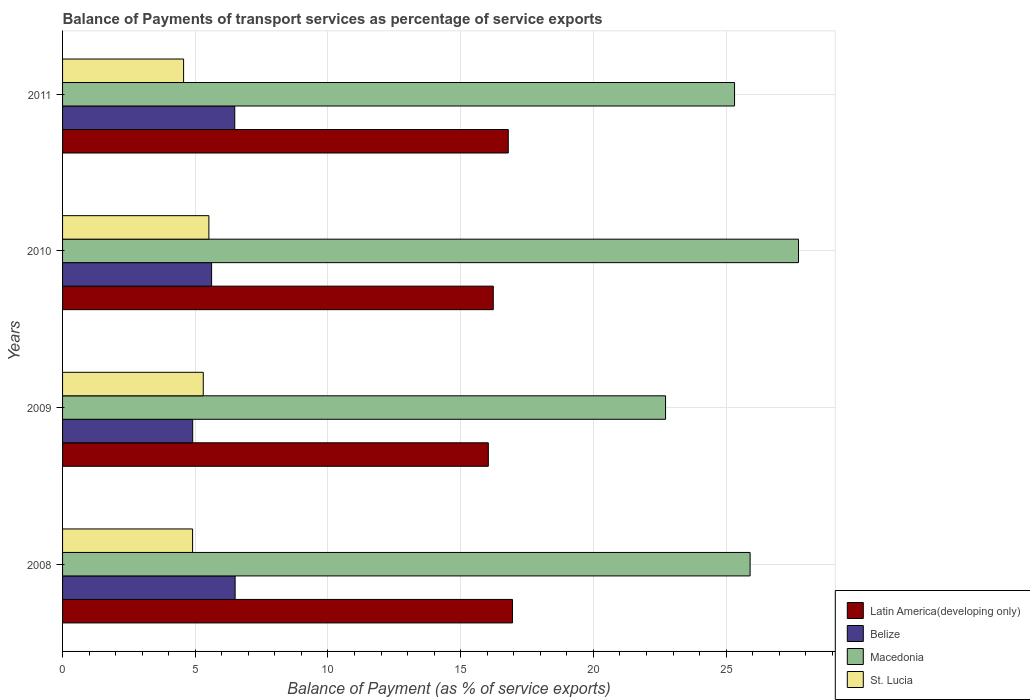How many different coloured bars are there?
Provide a short and direct response. 4. Are the number of bars per tick equal to the number of legend labels?
Ensure brevity in your answer.  Yes. Are the number of bars on each tick of the Y-axis equal?
Your answer should be very brief. Yes. How many bars are there on the 2nd tick from the top?
Make the answer very short. 4. How many bars are there on the 3rd tick from the bottom?
Your answer should be compact. 4. What is the label of the 4th group of bars from the top?
Offer a terse response. 2008. What is the balance of payments of transport services in Macedonia in 2008?
Your answer should be compact. 25.91. Across all years, what is the maximum balance of payments of transport services in St. Lucia?
Keep it short and to the point. 5.51. Across all years, what is the minimum balance of payments of transport services in Latin America(developing only)?
Provide a succinct answer. 16.04. In which year was the balance of payments of transport services in Belize minimum?
Keep it short and to the point. 2009. What is the total balance of payments of transport services in Belize in the graph?
Offer a terse response. 23.51. What is the difference between the balance of payments of transport services in Latin America(developing only) in 2009 and that in 2010?
Provide a succinct answer. -0.19. What is the difference between the balance of payments of transport services in Belize in 2009 and the balance of payments of transport services in Latin America(developing only) in 2008?
Your answer should be very brief. -12.05. What is the average balance of payments of transport services in Belize per year?
Ensure brevity in your answer.  5.88. In the year 2008, what is the difference between the balance of payments of transport services in Belize and balance of payments of transport services in St. Lucia?
Your response must be concise. 1.6. In how many years, is the balance of payments of transport services in Belize greater than 23 %?
Provide a short and direct response. 0. What is the ratio of the balance of payments of transport services in Latin America(developing only) in 2010 to that in 2011?
Keep it short and to the point. 0.97. Is the balance of payments of transport services in Belize in 2008 less than that in 2010?
Ensure brevity in your answer.  No. Is the difference between the balance of payments of transport services in Belize in 2008 and 2010 greater than the difference between the balance of payments of transport services in St. Lucia in 2008 and 2010?
Keep it short and to the point. Yes. What is the difference between the highest and the second highest balance of payments of transport services in Latin America(developing only)?
Offer a very short reply. 0.16. What is the difference between the highest and the lowest balance of payments of transport services in Latin America(developing only)?
Provide a short and direct response. 0.91. Is it the case that in every year, the sum of the balance of payments of transport services in Belize and balance of payments of transport services in Macedonia is greater than the sum of balance of payments of transport services in St. Lucia and balance of payments of transport services in Latin America(developing only)?
Offer a very short reply. Yes. What does the 3rd bar from the top in 2010 represents?
Offer a terse response. Belize. What does the 4th bar from the bottom in 2011 represents?
Offer a very short reply. St. Lucia. How many years are there in the graph?
Offer a terse response. 4. What is the difference between two consecutive major ticks on the X-axis?
Give a very brief answer. 5. Does the graph contain any zero values?
Your response must be concise. No. Where does the legend appear in the graph?
Give a very brief answer. Bottom right. How are the legend labels stacked?
Your answer should be compact. Vertical. What is the title of the graph?
Ensure brevity in your answer.  Balance of Payments of transport services as percentage of service exports. What is the label or title of the X-axis?
Provide a short and direct response. Balance of Payment (as % of service exports). What is the label or title of the Y-axis?
Your answer should be compact. Years. What is the Balance of Payment (as % of service exports) in Latin America(developing only) in 2008?
Provide a short and direct response. 16.95. What is the Balance of Payment (as % of service exports) in Belize in 2008?
Provide a succinct answer. 6.5. What is the Balance of Payment (as % of service exports) of Macedonia in 2008?
Provide a succinct answer. 25.91. What is the Balance of Payment (as % of service exports) in St. Lucia in 2008?
Keep it short and to the point. 4.9. What is the Balance of Payment (as % of service exports) in Latin America(developing only) in 2009?
Offer a terse response. 16.04. What is the Balance of Payment (as % of service exports) in Belize in 2009?
Your response must be concise. 4.9. What is the Balance of Payment (as % of service exports) of Macedonia in 2009?
Offer a very short reply. 22.72. What is the Balance of Payment (as % of service exports) of St. Lucia in 2009?
Make the answer very short. 5.3. What is the Balance of Payment (as % of service exports) of Latin America(developing only) in 2010?
Your answer should be compact. 16.23. What is the Balance of Payment (as % of service exports) of Belize in 2010?
Keep it short and to the point. 5.62. What is the Balance of Payment (as % of service exports) in Macedonia in 2010?
Make the answer very short. 27.73. What is the Balance of Payment (as % of service exports) of St. Lucia in 2010?
Offer a very short reply. 5.51. What is the Balance of Payment (as % of service exports) in Latin America(developing only) in 2011?
Your answer should be very brief. 16.79. What is the Balance of Payment (as % of service exports) in Belize in 2011?
Give a very brief answer. 6.49. What is the Balance of Payment (as % of service exports) of Macedonia in 2011?
Your answer should be compact. 25.32. What is the Balance of Payment (as % of service exports) of St. Lucia in 2011?
Give a very brief answer. 4.56. Across all years, what is the maximum Balance of Payment (as % of service exports) in Latin America(developing only)?
Provide a succinct answer. 16.95. Across all years, what is the maximum Balance of Payment (as % of service exports) of Belize?
Make the answer very short. 6.5. Across all years, what is the maximum Balance of Payment (as % of service exports) in Macedonia?
Ensure brevity in your answer.  27.73. Across all years, what is the maximum Balance of Payment (as % of service exports) in St. Lucia?
Your answer should be very brief. 5.51. Across all years, what is the minimum Balance of Payment (as % of service exports) in Latin America(developing only)?
Keep it short and to the point. 16.04. Across all years, what is the minimum Balance of Payment (as % of service exports) in Belize?
Your response must be concise. 4.9. Across all years, what is the minimum Balance of Payment (as % of service exports) in Macedonia?
Your answer should be very brief. 22.72. Across all years, what is the minimum Balance of Payment (as % of service exports) in St. Lucia?
Your response must be concise. 4.56. What is the total Balance of Payment (as % of service exports) of Latin America(developing only) in the graph?
Offer a very short reply. 66.02. What is the total Balance of Payment (as % of service exports) in Belize in the graph?
Your answer should be compact. 23.51. What is the total Balance of Payment (as % of service exports) in Macedonia in the graph?
Your answer should be compact. 101.67. What is the total Balance of Payment (as % of service exports) of St. Lucia in the graph?
Give a very brief answer. 20.27. What is the difference between the Balance of Payment (as % of service exports) in Latin America(developing only) in 2008 and that in 2009?
Provide a short and direct response. 0.91. What is the difference between the Balance of Payment (as % of service exports) of Belize in 2008 and that in 2009?
Offer a very short reply. 1.6. What is the difference between the Balance of Payment (as % of service exports) in Macedonia in 2008 and that in 2009?
Provide a succinct answer. 3.19. What is the difference between the Balance of Payment (as % of service exports) in St. Lucia in 2008 and that in 2009?
Make the answer very short. -0.4. What is the difference between the Balance of Payment (as % of service exports) of Latin America(developing only) in 2008 and that in 2010?
Your response must be concise. 0.72. What is the difference between the Balance of Payment (as % of service exports) in Belize in 2008 and that in 2010?
Your answer should be compact. 0.89. What is the difference between the Balance of Payment (as % of service exports) in Macedonia in 2008 and that in 2010?
Offer a terse response. -1.82. What is the difference between the Balance of Payment (as % of service exports) of St. Lucia in 2008 and that in 2010?
Offer a very short reply. -0.61. What is the difference between the Balance of Payment (as % of service exports) of Latin America(developing only) in 2008 and that in 2011?
Your answer should be very brief. 0.16. What is the difference between the Balance of Payment (as % of service exports) in Belize in 2008 and that in 2011?
Keep it short and to the point. 0.01. What is the difference between the Balance of Payment (as % of service exports) of Macedonia in 2008 and that in 2011?
Keep it short and to the point. 0.59. What is the difference between the Balance of Payment (as % of service exports) in St. Lucia in 2008 and that in 2011?
Keep it short and to the point. 0.34. What is the difference between the Balance of Payment (as % of service exports) in Latin America(developing only) in 2009 and that in 2010?
Give a very brief answer. -0.19. What is the difference between the Balance of Payment (as % of service exports) in Belize in 2009 and that in 2010?
Provide a short and direct response. -0.71. What is the difference between the Balance of Payment (as % of service exports) in Macedonia in 2009 and that in 2010?
Give a very brief answer. -5.01. What is the difference between the Balance of Payment (as % of service exports) of St. Lucia in 2009 and that in 2010?
Your answer should be very brief. -0.21. What is the difference between the Balance of Payment (as % of service exports) in Latin America(developing only) in 2009 and that in 2011?
Keep it short and to the point. -0.75. What is the difference between the Balance of Payment (as % of service exports) in Belize in 2009 and that in 2011?
Your answer should be compact. -1.59. What is the difference between the Balance of Payment (as % of service exports) of Macedonia in 2009 and that in 2011?
Offer a terse response. -2.6. What is the difference between the Balance of Payment (as % of service exports) of St. Lucia in 2009 and that in 2011?
Provide a short and direct response. 0.74. What is the difference between the Balance of Payment (as % of service exports) in Latin America(developing only) in 2010 and that in 2011?
Your answer should be very brief. -0.56. What is the difference between the Balance of Payment (as % of service exports) in Belize in 2010 and that in 2011?
Your response must be concise. -0.87. What is the difference between the Balance of Payment (as % of service exports) in Macedonia in 2010 and that in 2011?
Offer a terse response. 2.41. What is the difference between the Balance of Payment (as % of service exports) of St. Lucia in 2010 and that in 2011?
Keep it short and to the point. 0.95. What is the difference between the Balance of Payment (as % of service exports) of Latin America(developing only) in 2008 and the Balance of Payment (as % of service exports) of Belize in 2009?
Your answer should be very brief. 12.05. What is the difference between the Balance of Payment (as % of service exports) of Latin America(developing only) in 2008 and the Balance of Payment (as % of service exports) of Macedonia in 2009?
Provide a succinct answer. -5.77. What is the difference between the Balance of Payment (as % of service exports) of Latin America(developing only) in 2008 and the Balance of Payment (as % of service exports) of St. Lucia in 2009?
Provide a succinct answer. 11.65. What is the difference between the Balance of Payment (as % of service exports) of Belize in 2008 and the Balance of Payment (as % of service exports) of Macedonia in 2009?
Give a very brief answer. -16.22. What is the difference between the Balance of Payment (as % of service exports) in Belize in 2008 and the Balance of Payment (as % of service exports) in St. Lucia in 2009?
Provide a short and direct response. 1.2. What is the difference between the Balance of Payment (as % of service exports) of Macedonia in 2008 and the Balance of Payment (as % of service exports) of St. Lucia in 2009?
Keep it short and to the point. 20.6. What is the difference between the Balance of Payment (as % of service exports) of Latin America(developing only) in 2008 and the Balance of Payment (as % of service exports) of Belize in 2010?
Your answer should be very brief. 11.34. What is the difference between the Balance of Payment (as % of service exports) in Latin America(developing only) in 2008 and the Balance of Payment (as % of service exports) in Macedonia in 2010?
Keep it short and to the point. -10.78. What is the difference between the Balance of Payment (as % of service exports) in Latin America(developing only) in 2008 and the Balance of Payment (as % of service exports) in St. Lucia in 2010?
Provide a succinct answer. 11.44. What is the difference between the Balance of Payment (as % of service exports) in Belize in 2008 and the Balance of Payment (as % of service exports) in Macedonia in 2010?
Offer a very short reply. -21.23. What is the difference between the Balance of Payment (as % of service exports) of Belize in 2008 and the Balance of Payment (as % of service exports) of St. Lucia in 2010?
Make the answer very short. 0.99. What is the difference between the Balance of Payment (as % of service exports) of Macedonia in 2008 and the Balance of Payment (as % of service exports) of St. Lucia in 2010?
Your response must be concise. 20.39. What is the difference between the Balance of Payment (as % of service exports) in Latin America(developing only) in 2008 and the Balance of Payment (as % of service exports) in Belize in 2011?
Offer a very short reply. 10.46. What is the difference between the Balance of Payment (as % of service exports) of Latin America(developing only) in 2008 and the Balance of Payment (as % of service exports) of Macedonia in 2011?
Make the answer very short. -8.37. What is the difference between the Balance of Payment (as % of service exports) in Latin America(developing only) in 2008 and the Balance of Payment (as % of service exports) in St. Lucia in 2011?
Keep it short and to the point. 12.39. What is the difference between the Balance of Payment (as % of service exports) in Belize in 2008 and the Balance of Payment (as % of service exports) in Macedonia in 2011?
Your answer should be compact. -18.82. What is the difference between the Balance of Payment (as % of service exports) of Belize in 2008 and the Balance of Payment (as % of service exports) of St. Lucia in 2011?
Make the answer very short. 1.94. What is the difference between the Balance of Payment (as % of service exports) in Macedonia in 2008 and the Balance of Payment (as % of service exports) in St. Lucia in 2011?
Keep it short and to the point. 21.35. What is the difference between the Balance of Payment (as % of service exports) in Latin America(developing only) in 2009 and the Balance of Payment (as % of service exports) in Belize in 2010?
Offer a terse response. 10.43. What is the difference between the Balance of Payment (as % of service exports) of Latin America(developing only) in 2009 and the Balance of Payment (as % of service exports) of Macedonia in 2010?
Provide a succinct answer. -11.69. What is the difference between the Balance of Payment (as % of service exports) of Latin America(developing only) in 2009 and the Balance of Payment (as % of service exports) of St. Lucia in 2010?
Your answer should be compact. 10.53. What is the difference between the Balance of Payment (as % of service exports) of Belize in 2009 and the Balance of Payment (as % of service exports) of Macedonia in 2010?
Offer a very short reply. -22.83. What is the difference between the Balance of Payment (as % of service exports) in Belize in 2009 and the Balance of Payment (as % of service exports) in St. Lucia in 2010?
Your answer should be compact. -0.61. What is the difference between the Balance of Payment (as % of service exports) in Macedonia in 2009 and the Balance of Payment (as % of service exports) in St. Lucia in 2010?
Make the answer very short. 17.21. What is the difference between the Balance of Payment (as % of service exports) of Latin America(developing only) in 2009 and the Balance of Payment (as % of service exports) of Belize in 2011?
Provide a succinct answer. 9.55. What is the difference between the Balance of Payment (as % of service exports) in Latin America(developing only) in 2009 and the Balance of Payment (as % of service exports) in Macedonia in 2011?
Your response must be concise. -9.28. What is the difference between the Balance of Payment (as % of service exports) in Latin America(developing only) in 2009 and the Balance of Payment (as % of service exports) in St. Lucia in 2011?
Provide a short and direct response. 11.48. What is the difference between the Balance of Payment (as % of service exports) of Belize in 2009 and the Balance of Payment (as % of service exports) of Macedonia in 2011?
Give a very brief answer. -20.42. What is the difference between the Balance of Payment (as % of service exports) in Belize in 2009 and the Balance of Payment (as % of service exports) in St. Lucia in 2011?
Offer a terse response. 0.34. What is the difference between the Balance of Payment (as % of service exports) in Macedonia in 2009 and the Balance of Payment (as % of service exports) in St. Lucia in 2011?
Offer a terse response. 18.16. What is the difference between the Balance of Payment (as % of service exports) in Latin America(developing only) in 2010 and the Balance of Payment (as % of service exports) in Belize in 2011?
Offer a very short reply. 9.74. What is the difference between the Balance of Payment (as % of service exports) in Latin America(developing only) in 2010 and the Balance of Payment (as % of service exports) in Macedonia in 2011?
Offer a terse response. -9.09. What is the difference between the Balance of Payment (as % of service exports) of Latin America(developing only) in 2010 and the Balance of Payment (as % of service exports) of St. Lucia in 2011?
Your response must be concise. 11.67. What is the difference between the Balance of Payment (as % of service exports) of Belize in 2010 and the Balance of Payment (as % of service exports) of Macedonia in 2011?
Your answer should be very brief. -19.7. What is the difference between the Balance of Payment (as % of service exports) of Belize in 2010 and the Balance of Payment (as % of service exports) of St. Lucia in 2011?
Offer a terse response. 1.06. What is the difference between the Balance of Payment (as % of service exports) in Macedonia in 2010 and the Balance of Payment (as % of service exports) in St. Lucia in 2011?
Your answer should be compact. 23.17. What is the average Balance of Payment (as % of service exports) in Latin America(developing only) per year?
Make the answer very short. 16.5. What is the average Balance of Payment (as % of service exports) in Belize per year?
Make the answer very short. 5.88. What is the average Balance of Payment (as % of service exports) in Macedonia per year?
Your answer should be compact. 25.42. What is the average Balance of Payment (as % of service exports) in St. Lucia per year?
Provide a short and direct response. 5.07. In the year 2008, what is the difference between the Balance of Payment (as % of service exports) in Latin America(developing only) and Balance of Payment (as % of service exports) in Belize?
Provide a succinct answer. 10.45. In the year 2008, what is the difference between the Balance of Payment (as % of service exports) of Latin America(developing only) and Balance of Payment (as % of service exports) of Macedonia?
Your answer should be compact. -8.95. In the year 2008, what is the difference between the Balance of Payment (as % of service exports) in Latin America(developing only) and Balance of Payment (as % of service exports) in St. Lucia?
Make the answer very short. 12.05. In the year 2008, what is the difference between the Balance of Payment (as % of service exports) of Belize and Balance of Payment (as % of service exports) of Macedonia?
Keep it short and to the point. -19.4. In the year 2008, what is the difference between the Balance of Payment (as % of service exports) in Belize and Balance of Payment (as % of service exports) in St. Lucia?
Provide a succinct answer. 1.6. In the year 2008, what is the difference between the Balance of Payment (as % of service exports) in Macedonia and Balance of Payment (as % of service exports) in St. Lucia?
Make the answer very short. 21.01. In the year 2009, what is the difference between the Balance of Payment (as % of service exports) of Latin America(developing only) and Balance of Payment (as % of service exports) of Belize?
Your answer should be very brief. 11.14. In the year 2009, what is the difference between the Balance of Payment (as % of service exports) of Latin America(developing only) and Balance of Payment (as % of service exports) of Macedonia?
Offer a terse response. -6.68. In the year 2009, what is the difference between the Balance of Payment (as % of service exports) in Latin America(developing only) and Balance of Payment (as % of service exports) in St. Lucia?
Your answer should be compact. 10.74. In the year 2009, what is the difference between the Balance of Payment (as % of service exports) of Belize and Balance of Payment (as % of service exports) of Macedonia?
Your response must be concise. -17.82. In the year 2009, what is the difference between the Balance of Payment (as % of service exports) of Belize and Balance of Payment (as % of service exports) of St. Lucia?
Provide a succinct answer. -0.4. In the year 2009, what is the difference between the Balance of Payment (as % of service exports) in Macedonia and Balance of Payment (as % of service exports) in St. Lucia?
Make the answer very short. 17.42. In the year 2010, what is the difference between the Balance of Payment (as % of service exports) in Latin America(developing only) and Balance of Payment (as % of service exports) in Belize?
Ensure brevity in your answer.  10.61. In the year 2010, what is the difference between the Balance of Payment (as % of service exports) of Latin America(developing only) and Balance of Payment (as % of service exports) of Macedonia?
Provide a short and direct response. -11.5. In the year 2010, what is the difference between the Balance of Payment (as % of service exports) of Latin America(developing only) and Balance of Payment (as % of service exports) of St. Lucia?
Your answer should be very brief. 10.72. In the year 2010, what is the difference between the Balance of Payment (as % of service exports) in Belize and Balance of Payment (as % of service exports) in Macedonia?
Your response must be concise. -22.11. In the year 2010, what is the difference between the Balance of Payment (as % of service exports) of Belize and Balance of Payment (as % of service exports) of St. Lucia?
Your response must be concise. 0.1. In the year 2010, what is the difference between the Balance of Payment (as % of service exports) in Macedonia and Balance of Payment (as % of service exports) in St. Lucia?
Your answer should be very brief. 22.22. In the year 2011, what is the difference between the Balance of Payment (as % of service exports) of Latin America(developing only) and Balance of Payment (as % of service exports) of Belize?
Offer a very short reply. 10.3. In the year 2011, what is the difference between the Balance of Payment (as % of service exports) of Latin America(developing only) and Balance of Payment (as % of service exports) of Macedonia?
Provide a succinct answer. -8.53. In the year 2011, what is the difference between the Balance of Payment (as % of service exports) of Latin America(developing only) and Balance of Payment (as % of service exports) of St. Lucia?
Keep it short and to the point. 12.23. In the year 2011, what is the difference between the Balance of Payment (as % of service exports) of Belize and Balance of Payment (as % of service exports) of Macedonia?
Make the answer very short. -18.83. In the year 2011, what is the difference between the Balance of Payment (as % of service exports) of Belize and Balance of Payment (as % of service exports) of St. Lucia?
Your answer should be compact. 1.93. In the year 2011, what is the difference between the Balance of Payment (as % of service exports) of Macedonia and Balance of Payment (as % of service exports) of St. Lucia?
Make the answer very short. 20.76. What is the ratio of the Balance of Payment (as % of service exports) of Latin America(developing only) in 2008 to that in 2009?
Offer a terse response. 1.06. What is the ratio of the Balance of Payment (as % of service exports) in Belize in 2008 to that in 2009?
Keep it short and to the point. 1.33. What is the ratio of the Balance of Payment (as % of service exports) in Macedonia in 2008 to that in 2009?
Give a very brief answer. 1.14. What is the ratio of the Balance of Payment (as % of service exports) of St. Lucia in 2008 to that in 2009?
Give a very brief answer. 0.92. What is the ratio of the Balance of Payment (as % of service exports) of Latin America(developing only) in 2008 to that in 2010?
Make the answer very short. 1.04. What is the ratio of the Balance of Payment (as % of service exports) in Belize in 2008 to that in 2010?
Keep it short and to the point. 1.16. What is the ratio of the Balance of Payment (as % of service exports) in Macedonia in 2008 to that in 2010?
Your answer should be very brief. 0.93. What is the ratio of the Balance of Payment (as % of service exports) of St. Lucia in 2008 to that in 2010?
Give a very brief answer. 0.89. What is the ratio of the Balance of Payment (as % of service exports) of Latin America(developing only) in 2008 to that in 2011?
Your response must be concise. 1.01. What is the ratio of the Balance of Payment (as % of service exports) of Belize in 2008 to that in 2011?
Your answer should be very brief. 1. What is the ratio of the Balance of Payment (as % of service exports) of Macedonia in 2008 to that in 2011?
Your answer should be very brief. 1.02. What is the ratio of the Balance of Payment (as % of service exports) in St. Lucia in 2008 to that in 2011?
Make the answer very short. 1.07. What is the ratio of the Balance of Payment (as % of service exports) of Belize in 2009 to that in 2010?
Give a very brief answer. 0.87. What is the ratio of the Balance of Payment (as % of service exports) in Macedonia in 2009 to that in 2010?
Provide a short and direct response. 0.82. What is the ratio of the Balance of Payment (as % of service exports) of St. Lucia in 2009 to that in 2010?
Keep it short and to the point. 0.96. What is the ratio of the Balance of Payment (as % of service exports) of Latin America(developing only) in 2009 to that in 2011?
Your response must be concise. 0.96. What is the ratio of the Balance of Payment (as % of service exports) in Belize in 2009 to that in 2011?
Provide a short and direct response. 0.76. What is the ratio of the Balance of Payment (as % of service exports) in Macedonia in 2009 to that in 2011?
Keep it short and to the point. 0.9. What is the ratio of the Balance of Payment (as % of service exports) in St. Lucia in 2009 to that in 2011?
Provide a succinct answer. 1.16. What is the ratio of the Balance of Payment (as % of service exports) in Latin America(developing only) in 2010 to that in 2011?
Ensure brevity in your answer.  0.97. What is the ratio of the Balance of Payment (as % of service exports) in Belize in 2010 to that in 2011?
Provide a short and direct response. 0.87. What is the ratio of the Balance of Payment (as % of service exports) in Macedonia in 2010 to that in 2011?
Your response must be concise. 1.1. What is the ratio of the Balance of Payment (as % of service exports) of St. Lucia in 2010 to that in 2011?
Offer a terse response. 1.21. What is the difference between the highest and the second highest Balance of Payment (as % of service exports) of Latin America(developing only)?
Make the answer very short. 0.16. What is the difference between the highest and the second highest Balance of Payment (as % of service exports) in Belize?
Give a very brief answer. 0.01. What is the difference between the highest and the second highest Balance of Payment (as % of service exports) of Macedonia?
Offer a terse response. 1.82. What is the difference between the highest and the second highest Balance of Payment (as % of service exports) in St. Lucia?
Your answer should be compact. 0.21. What is the difference between the highest and the lowest Balance of Payment (as % of service exports) of Latin America(developing only)?
Make the answer very short. 0.91. What is the difference between the highest and the lowest Balance of Payment (as % of service exports) of Belize?
Give a very brief answer. 1.6. What is the difference between the highest and the lowest Balance of Payment (as % of service exports) of Macedonia?
Provide a succinct answer. 5.01. What is the difference between the highest and the lowest Balance of Payment (as % of service exports) of St. Lucia?
Keep it short and to the point. 0.95. 